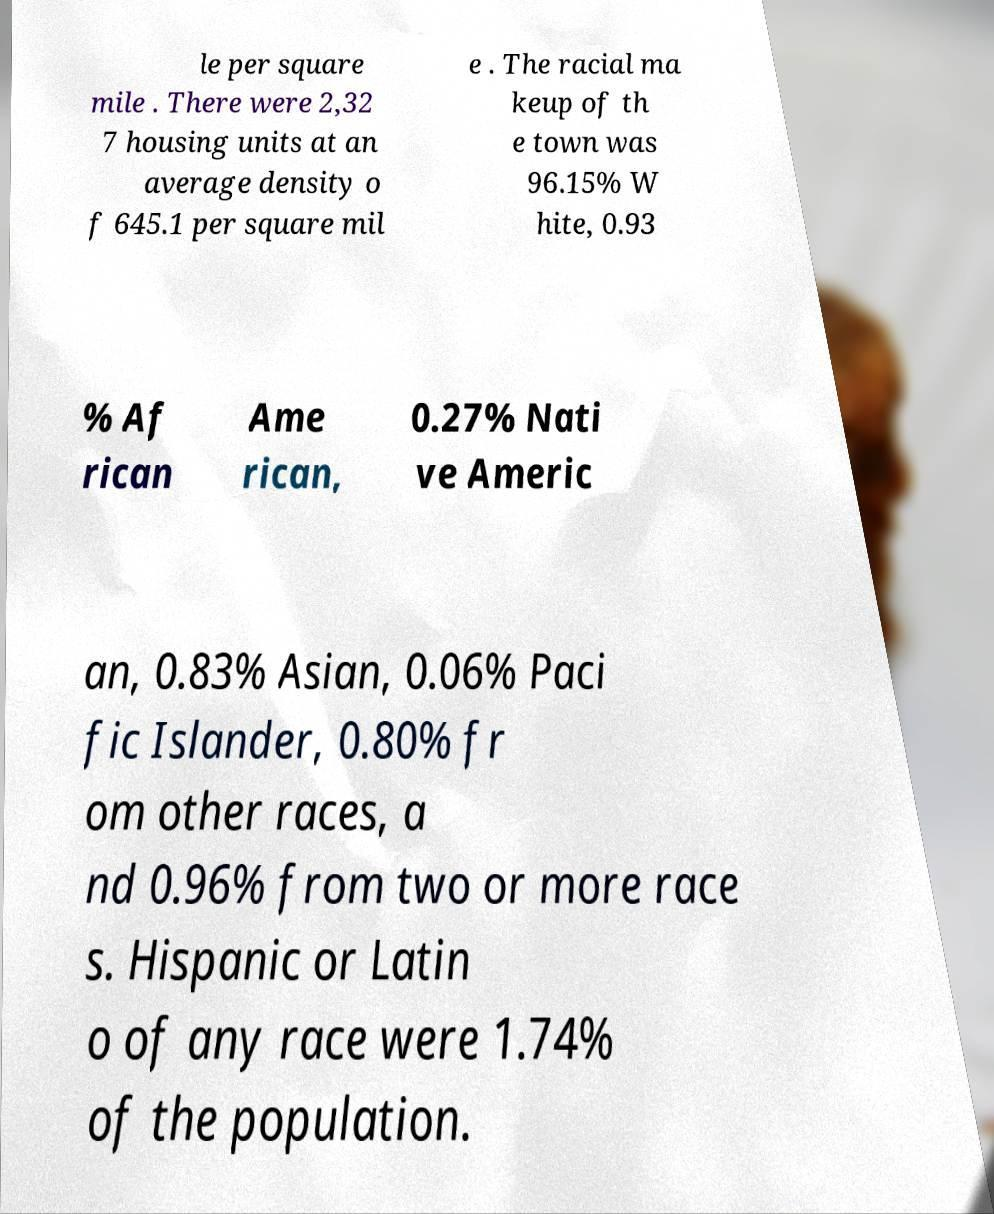Can you accurately transcribe the text from the provided image for me? le per square mile . There were 2,32 7 housing units at an average density o f 645.1 per square mil e . The racial ma keup of th e town was 96.15% W hite, 0.93 % Af rican Ame rican, 0.27% Nati ve Americ an, 0.83% Asian, 0.06% Paci fic Islander, 0.80% fr om other races, a nd 0.96% from two or more race s. Hispanic or Latin o of any race were 1.74% of the population. 